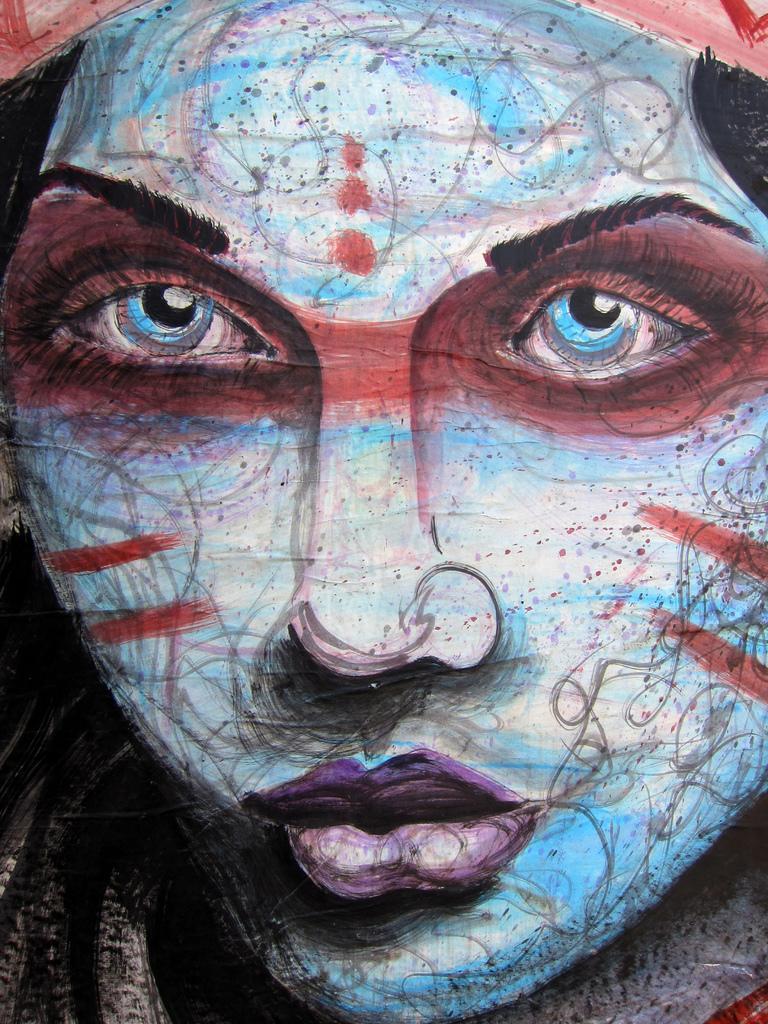Can you describe this image briefly? This looks like a painting. I can see the picture of a person's face. I can see the eyes, nose and mouth. 